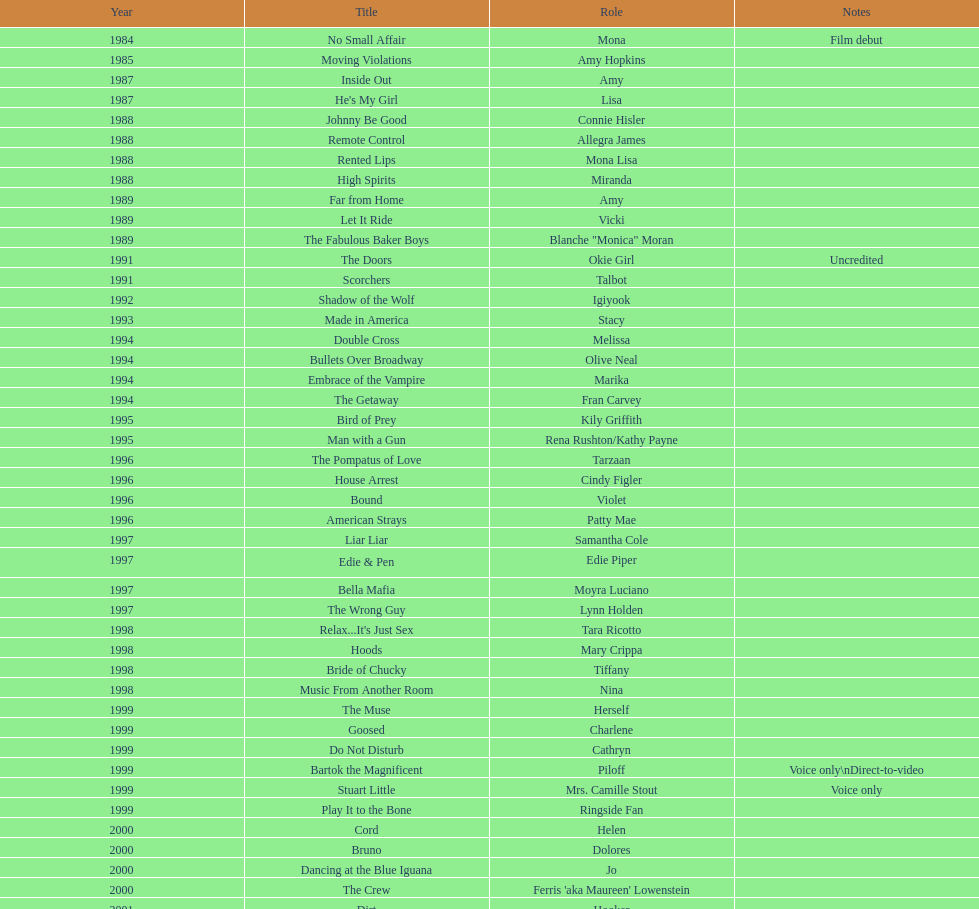How many motion pictures feature jennifer tilly playing herself? 4. 